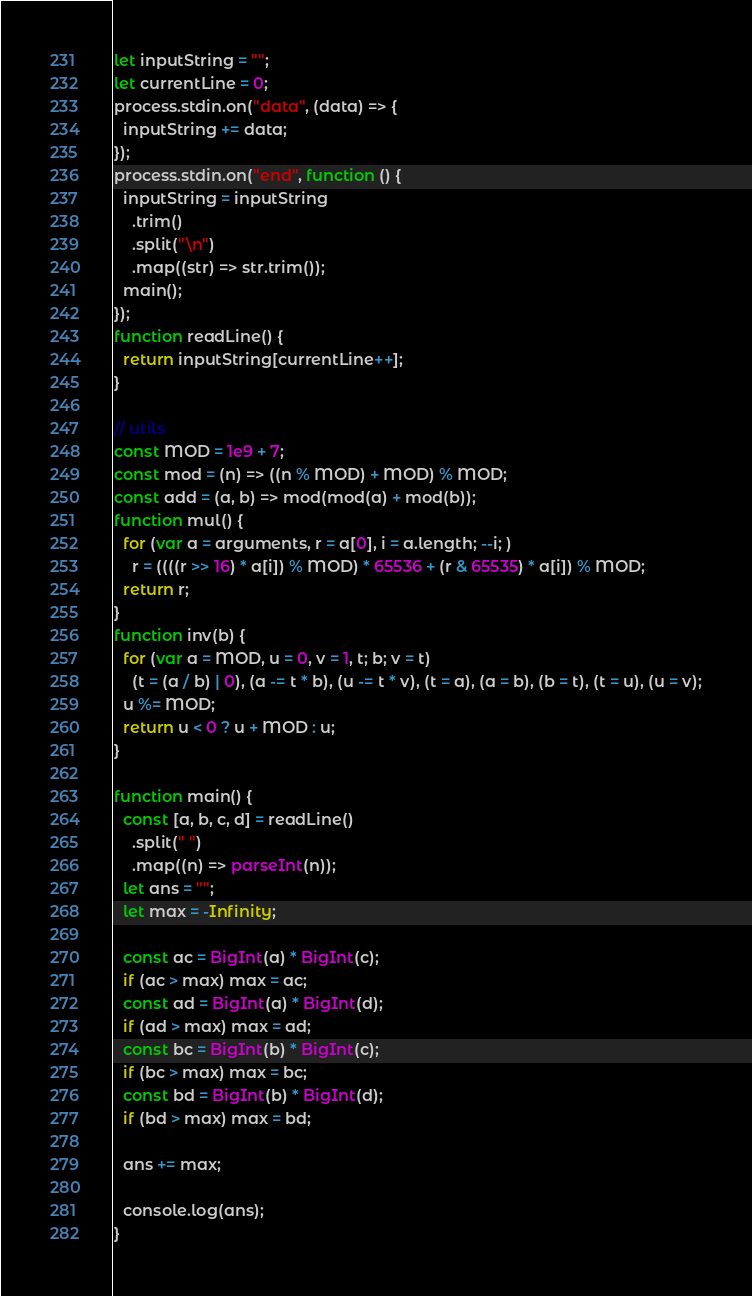Convert code to text. <code><loc_0><loc_0><loc_500><loc_500><_JavaScript_>let inputString = "";
let currentLine = 0;
process.stdin.on("data", (data) => {
  inputString += data;
});
process.stdin.on("end", function () {
  inputString = inputString
    .trim()
    .split("\n")
    .map((str) => str.trim());
  main();
});
function readLine() {
  return inputString[currentLine++];
}

// utils
const MOD = 1e9 + 7;
const mod = (n) => ((n % MOD) + MOD) % MOD;
const add = (a, b) => mod(mod(a) + mod(b));
function mul() {
  for (var a = arguments, r = a[0], i = a.length; --i; )
    r = ((((r >> 16) * a[i]) % MOD) * 65536 + (r & 65535) * a[i]) % MOD;
  return r;
}
function inv(b) {
  for (var a = MOD, u = 0, v = 1, t; b; v = t)
    (t = (a / b) | 0), (a -= t * b), (u -= t * v), (t = a), (a = b), (b = t), (t = u), (u = v);
  u %= MOD;
  return u < 0 ? u + MOD : u;
}

function main() {
  const [a, b, c, d] = readLine()
    .split(" ")
    .map((n) => parseInt(n));
  let ans = "";
  let max = -Infinity;

  const ac = BigInt(a) * BigInt(c);
  if (ac > max) max = ac;
  const ad = BigInt(a) * BigInt(d);
  if (ad > max) max = ad;
  const bc = BigInt(b) * BigInt(c);
  if (bc > max) max = bc;
  const bd = BigInt(b) * BigInt(d);
  if (bd > max) max = bd;

  ans += max;

  console.log(ans);
}
</code> 